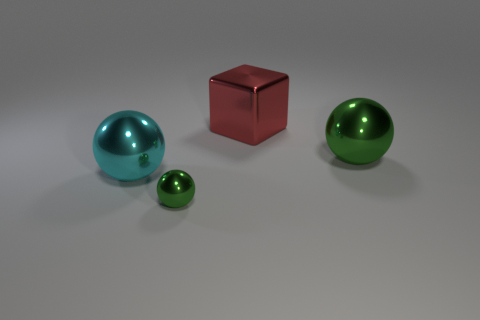Add 3 cubes. How many objects exist? 7 Subtract all balls. How many objects are left? 1 Add 4 cyan shiny things. How many cyan shiny things are left? 5 Add 4 cyan spheres. How many cyan spheres exist? 5 Subtract 0 blue blocks. How many objects are left? 4 Subtract all tiny brown rubber cylinders. Subtract all large metal objects. How many objects are left? 1 